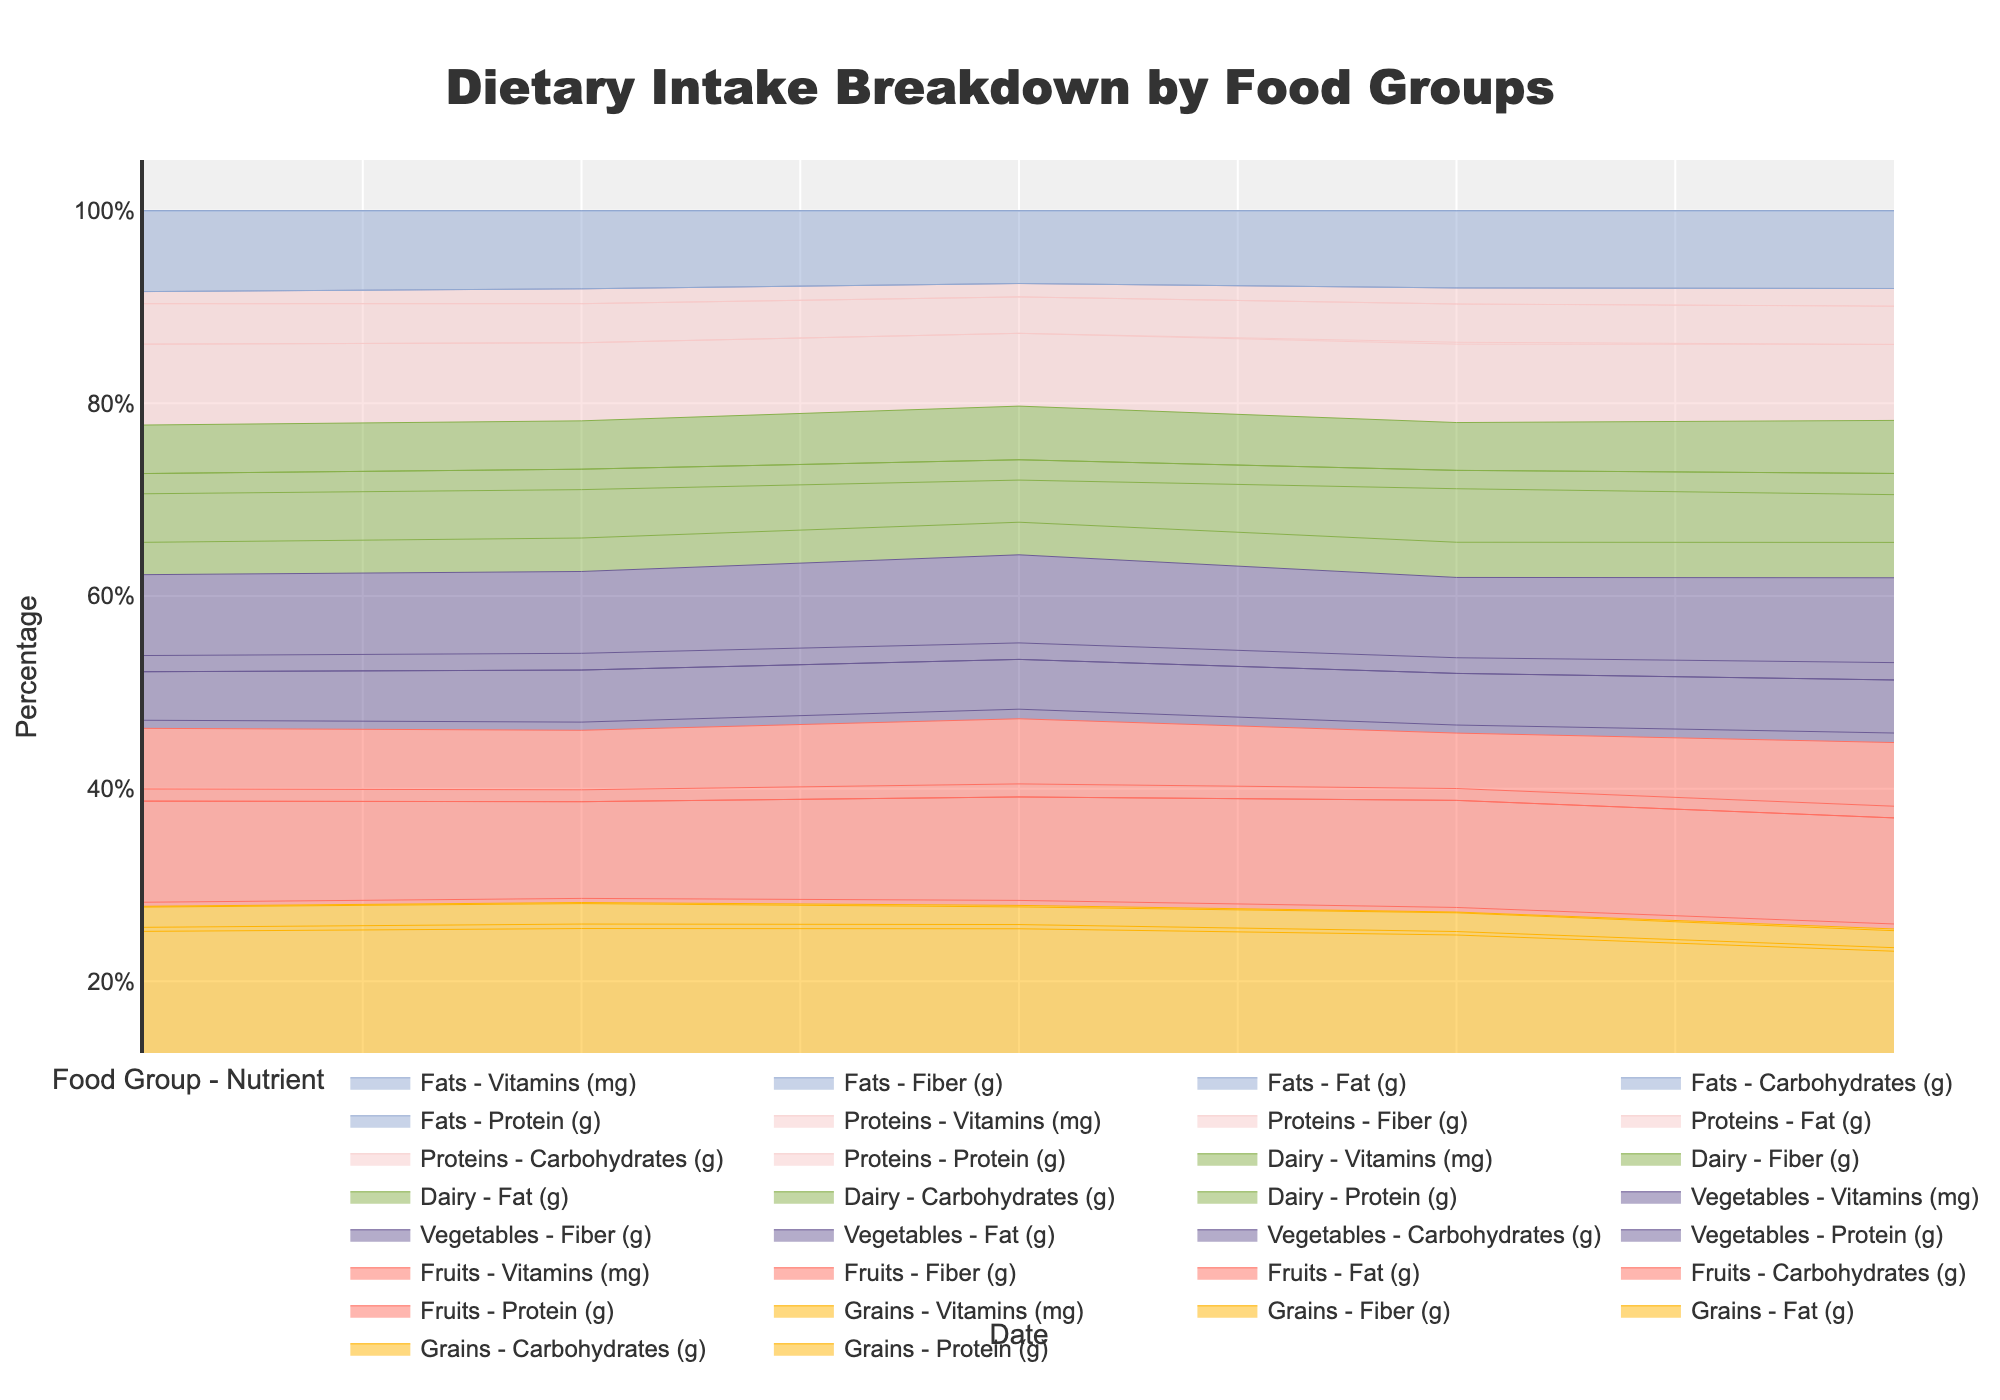What is the title of the chart? The title of an area chart is usually displayed at the top of the figure. In this case, it is found in the middle at the top, formatted in larger, bold text.
Answer: Dietary Intake Breakdown by Food Groups Which nutrients are represented on the y-axis? The y-axis title typically indicates what is being measured, and in this figure, it describes the nutrients as percentages.
Answer: Protein (g), Carbohydrates (g), Fat (g), Fiber (g), Vitamins (mg) On which date does the Protein Food Group contribute the most to the total nutrient intake? By observing the area covered by each food group over the dates provided, look for the date where the "Proteins" segment is the tallest relative to the others.
Answer: 2023-09-05 What percentage of the dietary intake is from Fats on September 1st? Locate the corresponding area for Fats on September 1st and compare it to the total height of the stack for that day. This would give an estimate of its contribution percentage-wise.
Answer: Approximately 24% How does the dietary intake from Dairy change from September 1 to September 5? Observe the relative increase or decrease in the area corresponding to Dairy over these dates. Summarize the trend, whether it increases, decreases, or fluctuates.
Answer: It slightly increases Which food group provides the most variety in nutrients? Examine which food group appears in multiple categories (Protein, Carbohydrates, Fat, Fiber, Vitamins) and covers a significant portion of the chart.
Answer: Dairy How does the intake of Carbohydrates from Grains compare on September 1 versus September 5? Identify the areas under the "Carbohydrates (g)" segment for Grains on both dates and compare their sizes.
Answer: It slightly decreases Is the Vitamin intake trend more consistent in Vegetables or Fruits? Compare the areas under "Vitamins (mg)" for both Vegetables and Fruits over the given dates and determine which has a more stable plot line.
Answer: Vegetables Which food group shows a steady increase in nutrient intake over the dates presented? Look for a food group whose segment area continuously grows larger without major fluctuations throughout the dates.
Answer: Fats What is the combined contribution of Proteins and Dairy towards Protein intake on 2023-09-03? Sum up the areas covered by Proteins and Dairy for "Protein (g)" on September 3. Visually, this would be the combined height of these segments on the chart for that day.
Answer: Approximately 27.5 g 